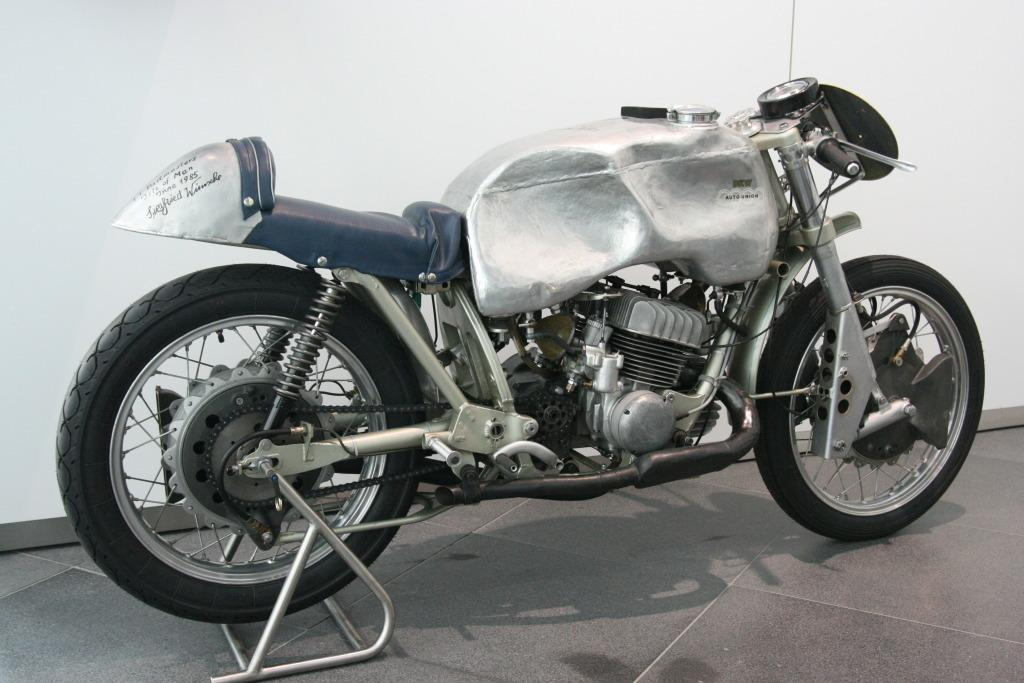What is the main subject of the image? The main subject of the image is a motorbike. Where is the motorbike located in the image? The motorbike is on the floor in the image. What can be seen in the background of the image? There is a wall in the background of the image. What type of rose can be seen growing on the wall in the image? There is no rose present in the image; the background only features a wall. 